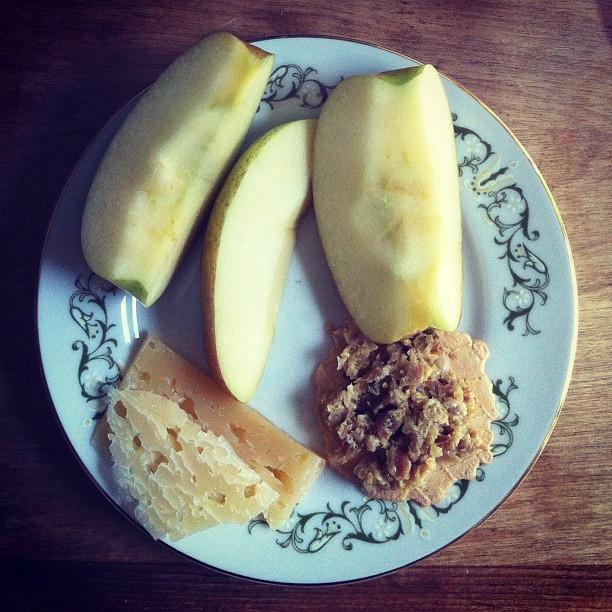How many pieces of apple are on the plate?
Give a very brief answer. 3. How many apples are there?
Give a very brief answer. 3. How many of the cows are calves?
Give a very brief answer. 0. 